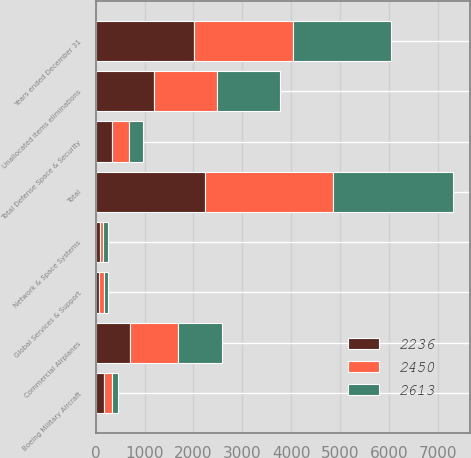Convert chart to OTSL. <chart><loc_0><loc_0><loc_500><loc_500><stacked_bar_chart><ecel><fcel>Years ended December 31<fcel>Commercial Airplanes<fcel>Boeing Military Aircraft<fcel>Network & Space Systems<fcel>Global Services & Support<fcel>Total Defense Space & Security<fcel>Unallocated items eliminations<fcel>Total<nl><fcel>2450<fcel>2016<fcel>993<fcel>161<fcel>63<fcel>112<fcel>336<fcel>1284<fcel>2613<nl><fcel>2613<fcel>2015<fcel>889<fcel>128<fcel>98<fcel>62<fcel>288<fcel>1273<fcel>2450<nl><fcel>2236<fcel>2014<fcel>698<fcel>175<fcel>93<fcel>68<fcel>336<fcel>1202<fcel>2236<nl></chart> 